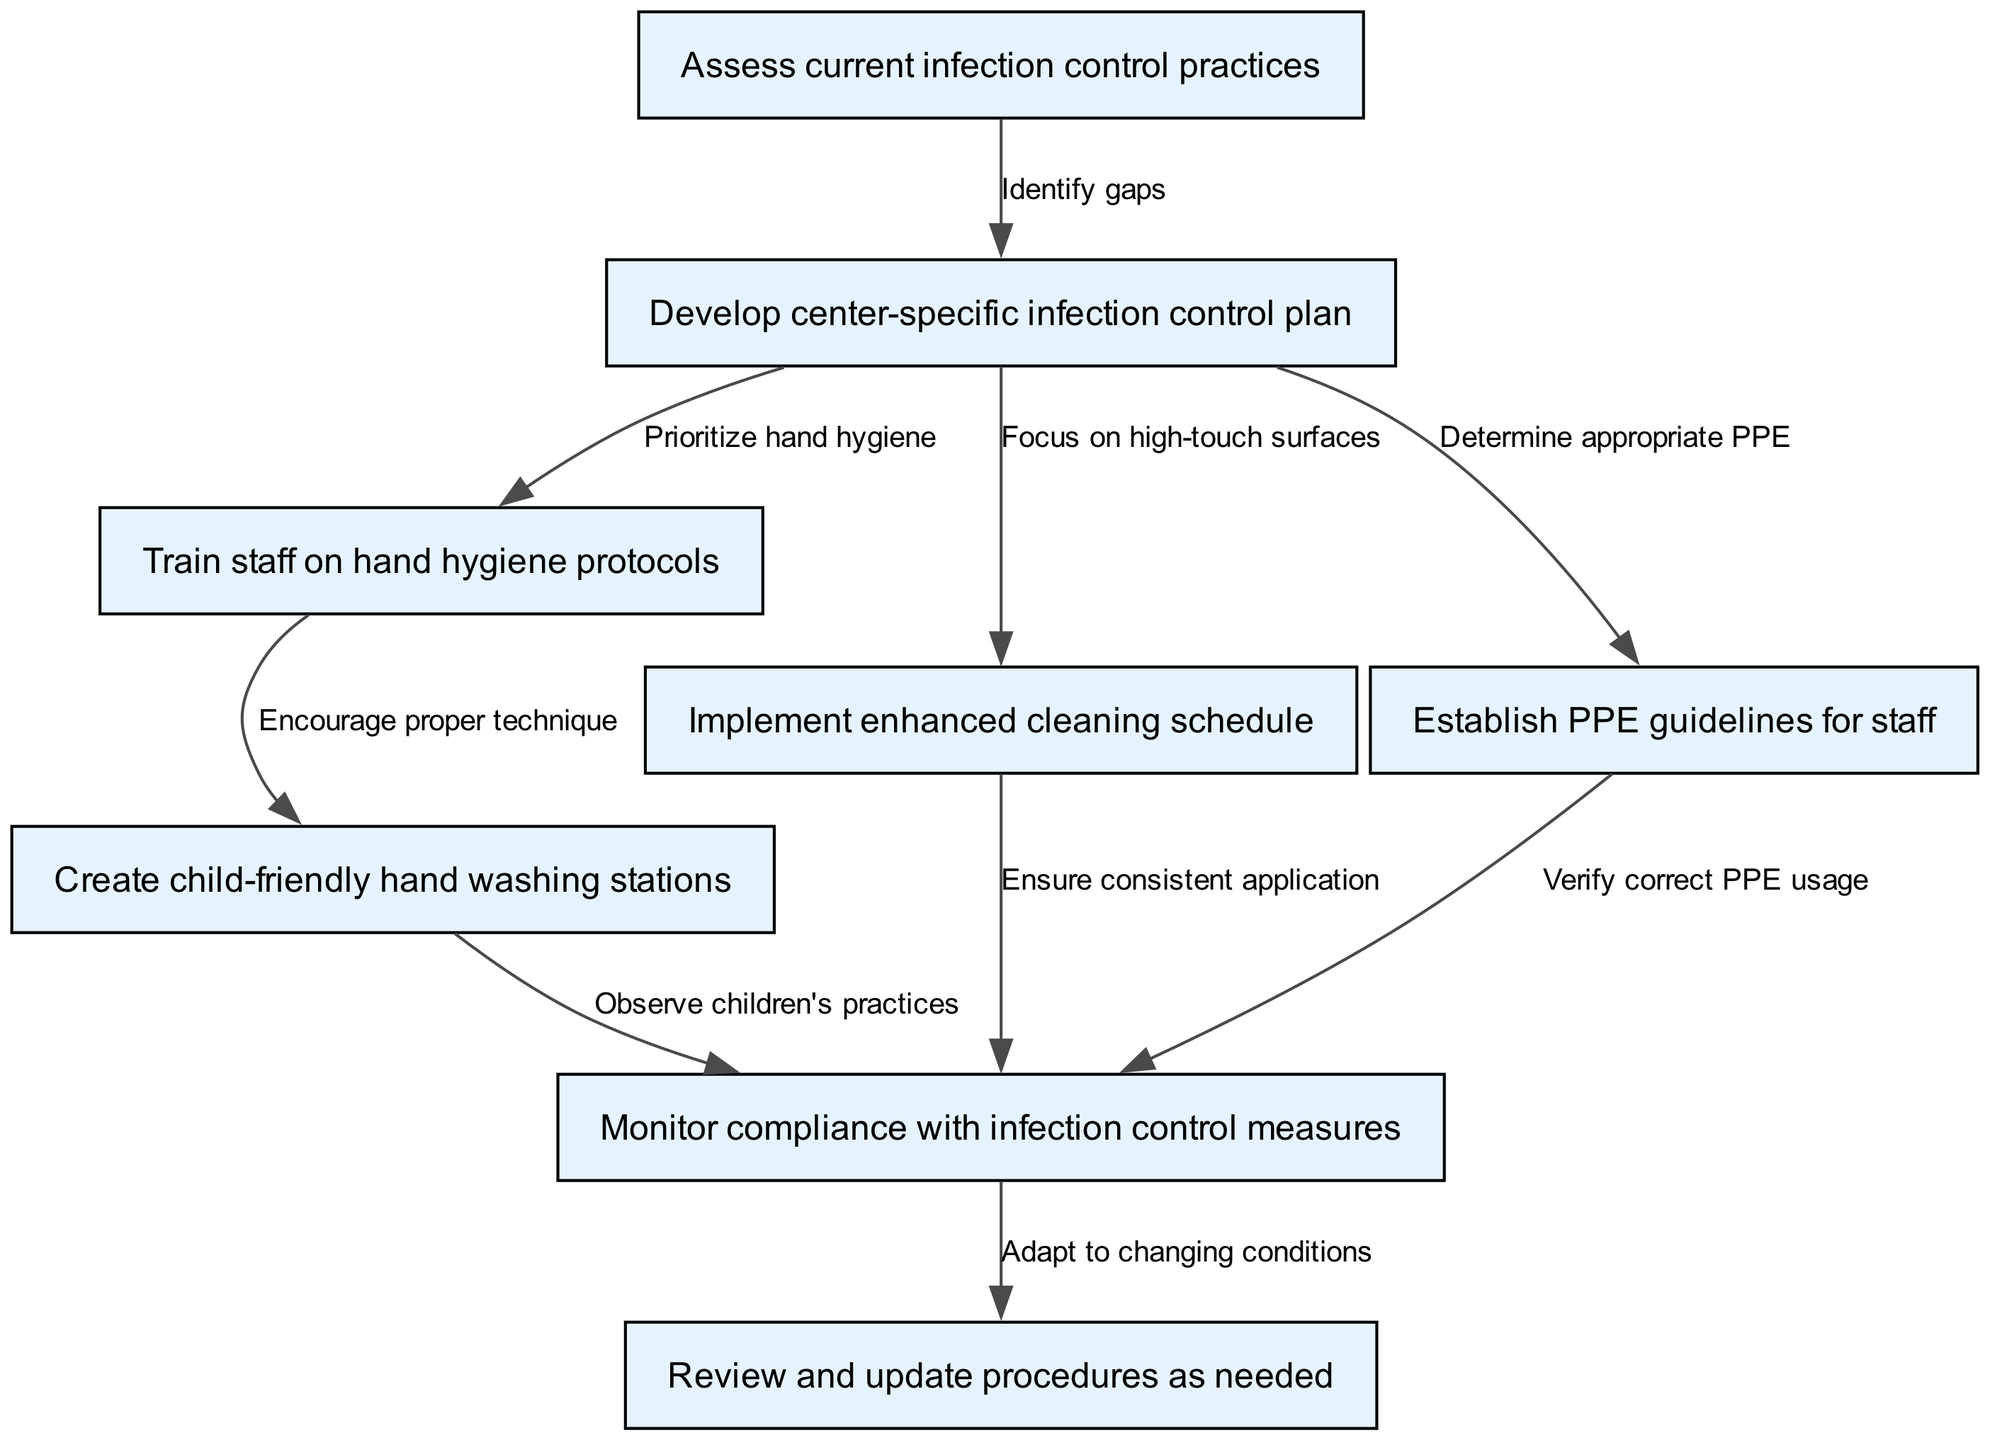What is the first step in the clinical pathway? The first step listed in the diagram is "Assess current infection control practices." This is indicated as the first node from which all other nodes branch or connect.
Answer: Assess current infection control practices How many nodes are present in the diagram? By counting the nodes listed in the provided data, there are a total of eight nodes that represent various steps in the infection prevention pathway.
Answer: 8 What is the relationship between "Develop center-specific infection control plan" and "Train staff on hand hygiene protocols"? The diagram shows a directed edge from node "2" (Develop center-specific infection control plan) to node "3" (Train staff on hand hygiene protocols). This indicates that the training of staff is prioritized after the development of the infection control plan.
Answer: Prioritize hand hygiene Which node focuses on enhancing cleaning schedules? The node that specifically indicates the focus on enhancing cleaning schedules is "Implement enhanced cleaning schedule," which is directly connected to the development of the infection control plan.
Answer: Implement enhanced cleaning schedule What is the last step in the clinical pathway? The last step in the diagram is "Review and update procedures as needed," which is the terminal node of the pathway reflecting the need for ongoing assessment and adaptation.
Answer: Review and update procedures as needed How does the "Establish PPE guidelines for staff" relate to compliance monitoring? The "Establish PPE guidelines for staff" node connects directly to the compliance monitoring node, indicating that verifying the correct use of personal protective equipment is part of the monitoring process.
Answer: Verify correct PPE usage What does the edge from "Create child-friendly hand washing stations" indicate? The edge from "Create child-friendly hand washing stations" to "Monitor compliance with infection control measures" indicates that observing children's handwashing practices is a part of the overall compliance monitoring efforts in the pathway.
Answer: Observe children's practices Which nodes are specifically related to hand hygiene? The nodes specifically related to hand hygiene are "Train staff on hand hygiene protocols" and "Create child-friendly hand washing stations," indicating a focus on both staff training and children's handwashing setups.
Answer: Train staff on hand hygiene protocols, Create child-friendly hand washing stations What should be done after monitoring compliance with infection control measures? After monitoring compliance, the next step is to "Review and update procedures as needed," which indicates that adaptations may be necessary based on the monitoring results.
Answer: Review and update procedures as needed 